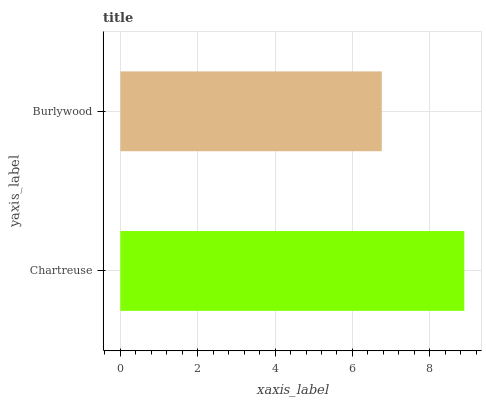Is Burlywood the minimum?
Answer yes or no. Yes. Is Chartreuse the maximum?
Answer yes or no. Yes. Is Burlywood the maximum?
Answer yes or no. No. Is Chartreuse greater than Burlywood?
Answer yes or no. Yes. Is Burlywood less than Chartreuse?
Answer yes or no. Yes. Is Burlywood greater than Chartreuse?
Answer yes or no. No. Is Chartreuse less than Burlywood?
Answer yes or no. No. Is Chartreuse the high median?
Answer yes or no. Yes. Is Burlywood the low median?
Answer yes or no. Yes. Is Burlywood the high median?
Answer yes or no. No. Is Chartreuse the low median?
Answer yes or no. No. 